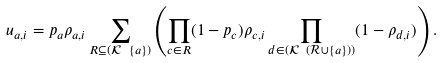Convert formula to latex. <formula><loc_0><loc_0><loc_500><loc_500>u _ { a , i } = p _ { a } \rho _ { a , i } \sum _ { R \subseteq ( \mathcal { K } \ \{ a \} ) } \left ( \prod _ { c \in R } ( 1 - p _ { c } ) \rho _ { c , i } \prod _ { d \in ( \mathcal { K } \ ( \mathcal { R } \cup \{ a \} ) ) } ( 1 - \rho _ { d , i } ) \right ) .</formula> 